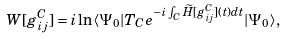Convert formula to latex. <formula><loc_0><loc_0><loc_500><loc_500>W [ g ^ { C } _ { i j } ] = i \ln \langle \Psi _ { 0 } | T _ { C } e ^ { - i \int _ { C } \widetilde { H } [ g _ { i j } ^ { C } ] ( t ) d t } | \Psi _ { 0 } \rangle ,</formula> 